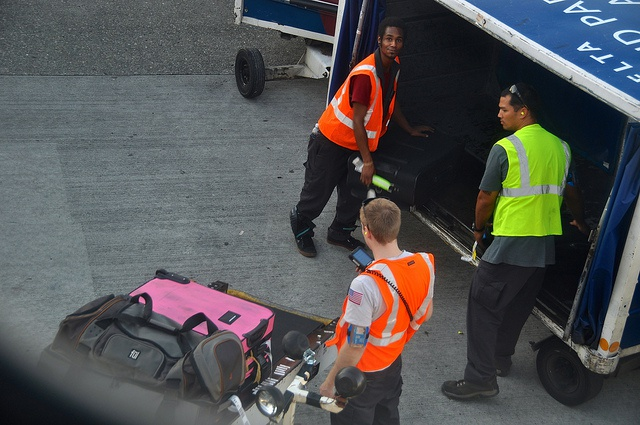Describe the objects in this image and their specific colors. I can see people in black, lime, gray, and olive tones, people in black, red, darkgray, and gray tones, people in black, maroon, and red tones, handbag in black and gray tones, and suitcase in black, gray, and purple tones in this image. 